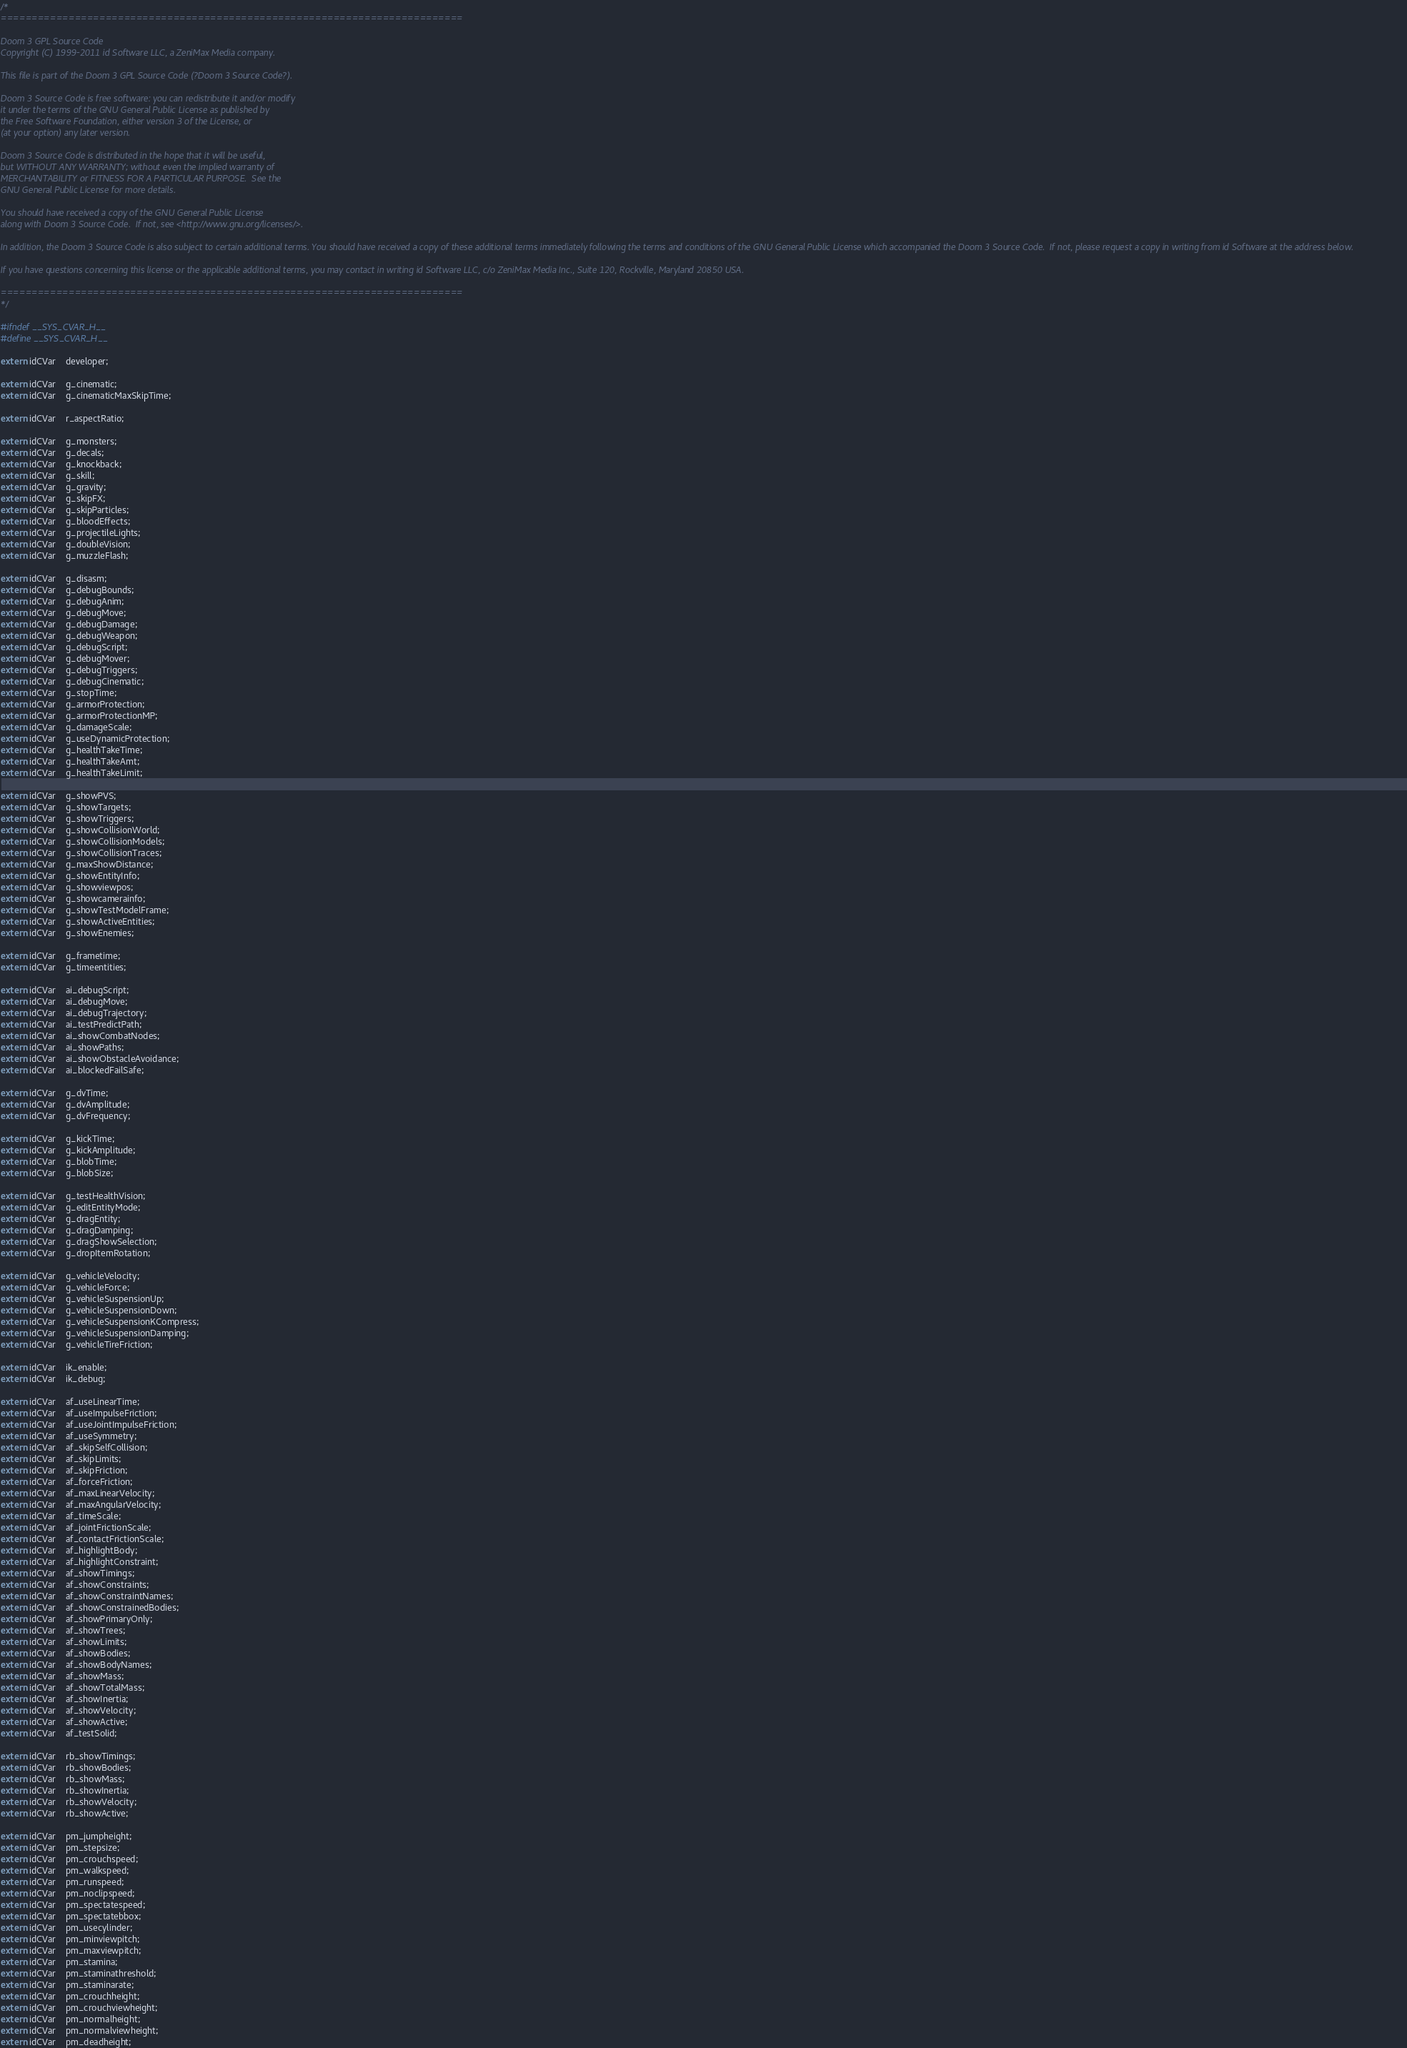Convert code to text. <code><loc_0><loc_0><loc_500><loc_500><_C_>/*
===========================================================================

Doom 3 GPL Source Code
Copyright (C) 1999-2011 id Software LLC, a ZeniMax Media company. 

This file is part of the Doom 3 GPL Source Code (?Doom 3 Source Code?).  

Doom 3 Source Code is free software: you can redistribute it and/or modify
it under the terms of the GNU General Public License as published by
the Free Software Foundation, either version 3 of the License, or
(at your option) any later version.

Doom 3 Source Code is distributed in the hope that it will be useful,
but WITHOUT ANY WARRANTY; without even the implied warranty of
MERCHANTABILITY or FITNESS FOR A PARTICULAR PURPOSE.  See the
GNU General Public License for more details.

You should have received a copy of the GNU General Public License
along with Doom 3 Source Code.  If not, see <http://www.gnu.org/licenses/>.

In addition, the Doom 3 Source Code is also subject to certain additional terms. You should have received a copy of these additional terms immediately following the terms and conditions of the GNU General Public License which accompanied the Doom 3 Source Code.  If not, please request a copy in writing from id Software at the address below.

If you have questions concerning this license or the applicable additional terms, you may contact in writing id Software LLC, c/o ZeniMax Media Inc., Suite 120, Rockville, Maryland 20850 USA.

===========================================================================
*/

#ifndef __SYS_CVAR_H__
#define __SYS_CVAR_H__

extern idCVar	developer;

extern idCVar	g_cinematic;
extern idCVar	g_cinematicMaxSkipTime;

extern idCVar	r_aspectRatio;

extern idCVar	g_monsters;
extern idCVar	g_decals;
extern idCVar	g_knockback;
extern idCVar	g_skill;
extern idCVar	g_gravity;
extern idCVar	g_skipFX;
extern idCVar	g_skipParticles;
extern idCVar	g_bloodEffects;
extern idCVar	g_projectileLights;
extern idCVar	g_doubleVision;
extern idCVar	g_muzzleFlash;

extern idCVar	g_disasm;
extern idCVar	g_debugBounds;
extern idCVar	g_debugAnim;
extern idCVar	g_debugMove;
extern idCVar	g_debugDamage;
extern idCVar	g_debugWeapon;
extern idCVar	g_debugScript;
extern idCVar	g_debugMover;
extern idCVar	g_debugTriggers;
extern idCVar	g_debugCinematic;
extern idCVar	g_stopTime;
extern idCVar	g_armorProtection;
extern idCVar	g_armorProtectionMP;
extern idCVar	g_damageScale;
extern idCVar	g_useDynamicProtection;
extern idCVar	g_healthTakeTime;
extern idCVar	g_healthTakeAmt;
extern idCVar	g_healthTakeLimit;

extern idCVar	g_showPVS;
extern idCVar	g_showTargets;
extern idCVar	g_showTriggers;
extern idCVar	g_showCollisionWorld;
extern idCVar	g_showCollisionModels;
extern idCVar	g_showCollisionTraces;
extern idCVar	g_maxShowDistance;
extern idCVar	g_showEntityInfo;
extern idCVar	g_showviewpos;
extern idCVar	g_showcamerainfo;
extern idCVar	g_showTestModelFrame;
extern idCVar	g_showActiveEntities;
extern idCVar	g_showEnemies;

extern idCVar	g_frametime;
extern idCVar	g_timeentities;

extern idCVar	ai_debugScript;
extern idCVar	ai_debugMove;
extern idCVar	ai_debugTrajectory;
extern idCVar	ai_testPredictPath;
extern idCVar	ai_showCombatNodes;
extern idCVar	ai_showPaths;
extern idCVar	ai_showObstacleAvoidance;
extern idCVar	ai_blockedFailSafe;

extern idCVar	g_dvTime;
extern idCVar	g_dvAmplitude;
extern idCVar	g_dvFrequency;

extern idCVar	g_kickTime;
extern idCVar	g_kickAmplitude;
extern idCVar	g_blobTime;
extern idCVar	g_blobSize;

extern idCVar	g_testHealthVision;
extern idCVar	g_editEntityMode;
extern idCVar	g_dragEntity;
extern idCVar	g_dragDamping;
extern idCVar	g_dragShowSelection;
extern idCVar	g_dropItemRotation;

extern idCVar	g_vehicleVelocity;
extern idCVar	g_vehicleForce;
extern idCVar	g_vehicleSuspensionUp;
extern idCVar	g_vehicleSuspensionDown;
extern idCVar	g_vehicleSuspensionKCompress;
extern idCVar	g_vehicleSuspensionDamping;
extern idCVar	g_vehicleTireFriction;

extern idCVar	ik_enable;
extern idCVar	ik_debug;

extern idCVar	af_useLinearTime;
extern idCVar	af_useImpulseFriction;
extern idCVar	af_useJointImpulseFriction;
extern idCVar	af_useSymmetry;
extern idCVar	af_skipSelfCollision;
extern idCVar	af_skipLimits;
extern idCVar	af_skipFriction;
extern idCVar	af_forceFriction;
extern idCVar	af_maxLinearVelocity;
extern idCVar	af_maxAngularVelocity;
extern idCVar	af_timeScale;
extern idCVar	af_jointFrictionScale;
extern idCVar	af_contactFrictionScale;
extern idCVar	af_highlightBody;
extern idCVar	af_highlightConstraint;
extern idCVar	af_showTimings;
extern idCVar	af_showConstraints;
extern idCVar	af_showConstraintNames;
extern idCVar	af_showConstrainedBodies;
extern idCVar	af_showPrimaryOnly;
extern idCVar	af_showTrees;
extern idCVar	af_showLimits;
extern idCVar	af_showBodies;
extern idCVar	af_showBodyNames;
extern idCVar	af_showMass;
extern idCVar	af_showTotalMass;
extern idCVar	af_showInertia;
extern idCVar	af_showVelocity;
extern idCVar	af_showActive;
extern idCVar	af_testSolid;

extern idCVar	rb_showTimings;
extern idCVar	rb_showBodies;
extern idCVar	rb_showMass;
extern idCVar	rb_showInertia;
extern idCVar	rb_showVelocity;
extern idCVar	rb_showActive;

extern idCVar	pm_jumpheight;
extern idCVar	pm_stepsize;
extern idCVar	pm_crouchspeed;
extern idCVar	pm_walkspeed;
extern idCVar	pm_runspeed;
extern idCVar	pm_noclipspeed;
extern idCVar	pm_spectatespeed;
extern idCVar	pm_spectatebbox;
extern idCVar	pm_usecylinder;
extern idCVar	pm_minviewpitch;
extern idCVar	pm_maxviewpitch;
extern idCVar	pm_stamina;
extern idCVar	pm_staminathreshold;
extern idCVar	pm_staminarate;
extern idCVar	pm_crouchheight;
extern idCVar	pm_crouchviewheight;
extern idCVar	pm_normalheight;
extern idCVar	pm_normalviewheight;
extern idCVar	pm_deadheight;</code> 